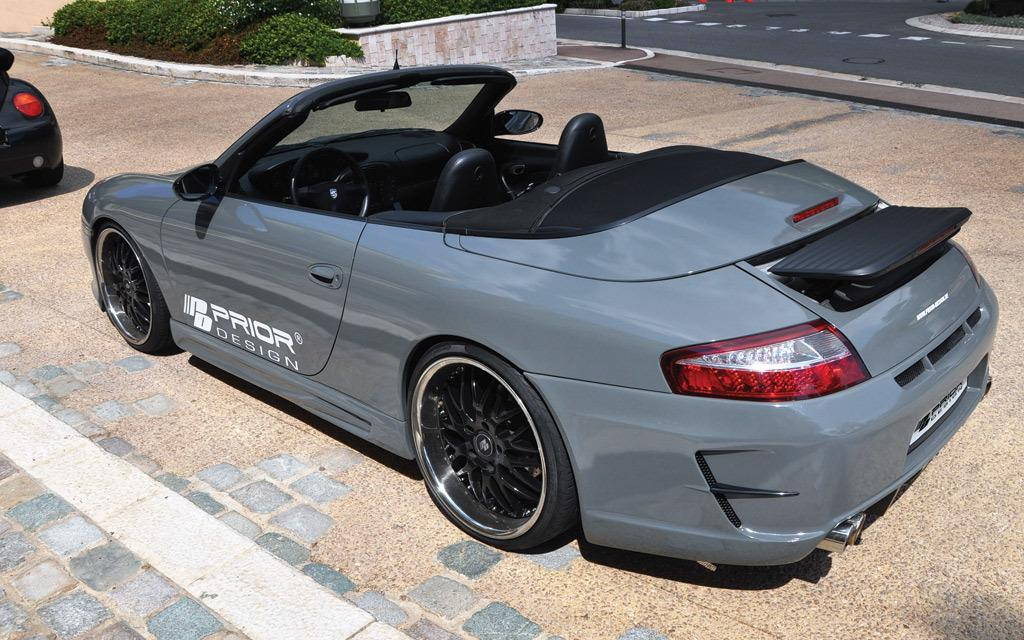How many cars are in the parking in the image? There are two cars in the parking in the image. What is located near the parking? There is a road near the parking. What can be seen near the road? There are plants near the road. Is there any text visible on any of the cars? Yes, there is some text on one of the cars. Reasoning: Let'g: Let's think step by step in order to describe the scene accurately. We start by identifying the main subjects and objects in the image based on the provided facts. We then formulate questions that focus on the location and characteristics of these subjects and objects, ensuring that each question can be answered definitively with the information given. We avoid yes/no questions and ensure that the language is simple and clear. Absurd Question/Answer: Can you see the ocean in the background of the image? There is no ocean visible in the image; it features a parking lot, a road, and plants. What type of cord is connected to the car in the image? There is no cord connected to any of the cars in the image. What type of cord is connected to the car in the image? There is no cord connected to any of the cars in the image. 